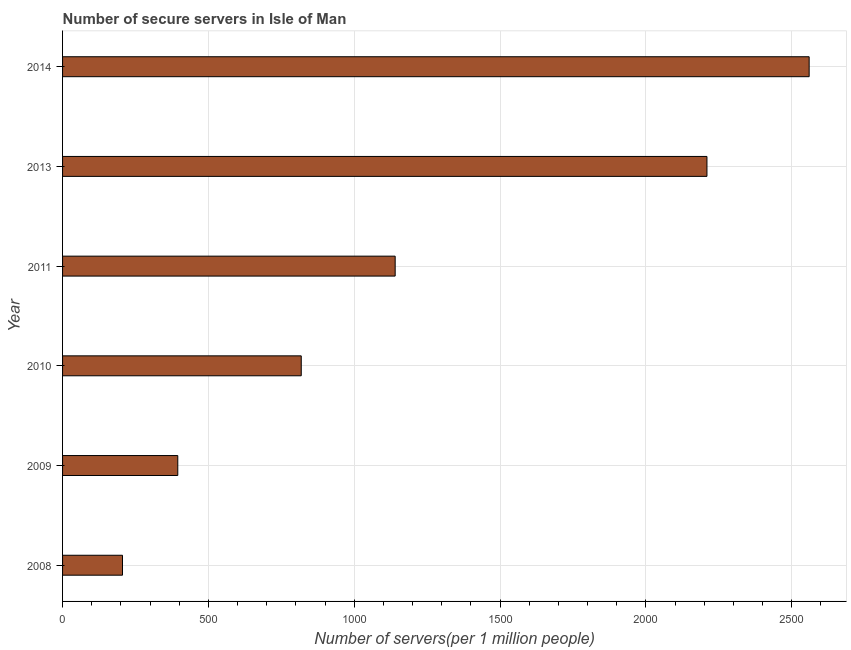Does the graph contain grids?
Provide a succinct answer. Yes. What is the title of the graph?
Keep it short and to the point. Number of secure servers in Isle of Man. What is the label or title of the X-axis?
Your answer should be very brief. Number of servers(per 1 million people). What is the number of secure internet servers in 2010?
Ensure brevity in your answer.  818.24. Across all years, what is the maximum number of secure internet servers?
Ensure brevity in your answer.  2559.48. Across all years, what is the minimum number of secure internet servers?
Provide a succinct answer. 205.47. What is the sum of the number of secure internet servers?
Provide a short and direct response. 7327.49. What is the difference between the number of secure internet servers in 2009 and 2011?
Provide a succinct answer. -745.27. What is the average number of secure internet servers per year?
Give a very brief answer. 1221.25. What is the median number of secure internet servers?
Provide a succinct answer. 979.25. In how many years, is the number of secure internet servers greater than 1600 ?
Your answer should be compact. 2. Do a majority of the years between 2009 and 2011 (inclusive) have number of secure internet servers greater than 2000 ?
Ensure brevity in your answer.  No. What is the ratio of the number of secure internet servers in 2008 to that in 2011?
Make the answer very short. 0.18. Is the number of secure internet servers in 2008 less than that in 2010?
Make the answer very short. Yes. What is the difference between the highest and the second highest number of secure internet servers?
Give a very brief answer. 350.42. Is the sum of the number of secure internet servers in 2008 and 2013 greater than the maximum number of secure internet servers across all years?
Your answer should be very brief. No. What is the difference between the highest and the lowest number of secure internet servers?
Provide a short and direct response. 2354.01. In how many years, is the number of secure internet servers greater than the average number of secure internet servers taken over all years?
Your response must be concise. 2. Are all the bars in the graph horizontal?
Your answer should be compact. Yes. What is the Number of servers(per 1 million people) of 2008?
Ensure brevity in your answer.  205.47. What is the Number of servers(per 1 million people) of 2009?
Make the answer very short. 394.98. What is the Number of servers(per 1 million people) of 2010?
Offer a terse response. 818.24. What is the Number of servers(per 1 million people) of 2011?
Your answer should be very brief. 1140.25. What is the Number of servers(per 1 million people) of 2013?
Give a very brief answer. 2209.06. What is the Number of servers(per 1 million people) of 2014?
Your answer should be very brief. 2559.48. What is the difference between the Number of servers(per 1 million people) in 2008 and 2009?
Your response must be concise. -189.51. What is the difference between the Number of servers(per 1 million people) in 2008 and 2010?
Your answer should be compact. -612.77. What is the difference between the Number of servers(per 1 million people) in 2008 and 2011?
Your response must be concise. -934.78. What is the difference between the Number of servers(per 1 million people) in 2008 and 2013?
Offer a very short reply. -2003.59. What is the difference between the Number of servers(per 1 million people) in 2008 and 2014?
Your answer should be compact. -2354.01. What is the difference between the Number of servers(per 1 million people) in 2009 and 2010?
Offer a terse response. -423.26. What is the difference between the Number of servers(per 1 million people) in 2009 and 2011?
Offer a very short reply. -745.27. What is the difference between the Number of servers(per 1 million people) in 2009 and 2013?
Make the answer very short. -1814.08. What is the difference between the Number of servers(per 1 million people) in 2009 and 2014?
Your answer should be very brief. -2164.5. What is the difference between the Number of servers(per 1 million people) in 2010 and 2011?
Offer a terse response. -322.01. What is the difference between the Number of servers(per 1 million people) in 2010 and 2013?
Ensure brevity in your answer.  -1390.82. What is the difference between the Number of servers(per 1 million people) in 2010 and 2014?
Your answer should be very brief. -1741.24. What is the difference between the Number of servers(per 1 million people) in 2011 and 2013?
Provide a succinct answer. -1068.81. What is the difference between the Number of servers(per 1 million people) in 2011 and 2014?
Your response must be concise. -1419.23. What is the difference between the Number of servers(per 1 million people) in 2013 and 2014?
Provide a succinct answer. -350.42. What is the ratio of the Number of servers(per 1 million people) in 2008 to that in 2009?
Your answer should be very brief. 0.52. What is the ratio of the Number of servers(per 1 million people) in 2008 to that in 2010?
Provide a succinct answer. 0.25. What is the ratio of the Number of servers(per 1 million people) in 2008 to that in 2011?
Your answer should be very brief. 0.18. What is the ratio of the Number of servers(per 1 million people) in 2008 to that in 2013?
Ensure brevity in your answer.  0.09. What is the ratio of the Number of servers(per 1 million people) in 2009 to that in 2010?
Keep it short and to the point. 0.48. What is the ratio of the Number of servers(per 1 million people) in 2009 to that in 2011?
Your response must be concise. 0.35. What is the ratio of the Number of servers(per 1 million people) in 2009 to that in 2013?
Make the answer very short. 0.18. What is the ratio of the Number of servers(per 1 million people) in 2009 to that in 2014?
Keep it short and to the point. 0.15. What is the ratio of the Number of servers(per 1 million people) in 2010 to that in 2011?
Your answer should be compact. 0.72. What is the ratio of the Number of servers(per 1 million people) in 2010 to that in 2013?
Provide a short and direct response. 0.37. What is the ratio of the Number of servers(per 1 million people) in 2010 to that in 2014?
Your response must be concise. 0.32. What is the ratio of the Number of servers(per 1 million people) in 2011 to that in 2013?
Provide a short and direct response. 0.52. What is the ratio of the Number of servers(per 1 million people) in 2011 to that in 2014?
Your answer should be compact. 0.45. What is the ratio of the Number of servers(per 1 million people) in 2013 to that in 2014?
Make the answer very short. 0.86. 